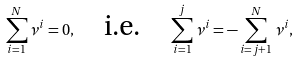Convert formula to latex. <formula><loc_0><loc_0><loc_500><loc_500>\sum _ { i = 1 } ^ { N } \nu ^ { i } = 0 , \quad \text {i.e.} \quad \sum _ { i = 1 } ^ { j } \nu ^ { i } = - \sum _ { i = j + 1 } ^ { N } \nu ^ { i } ,</formula> 